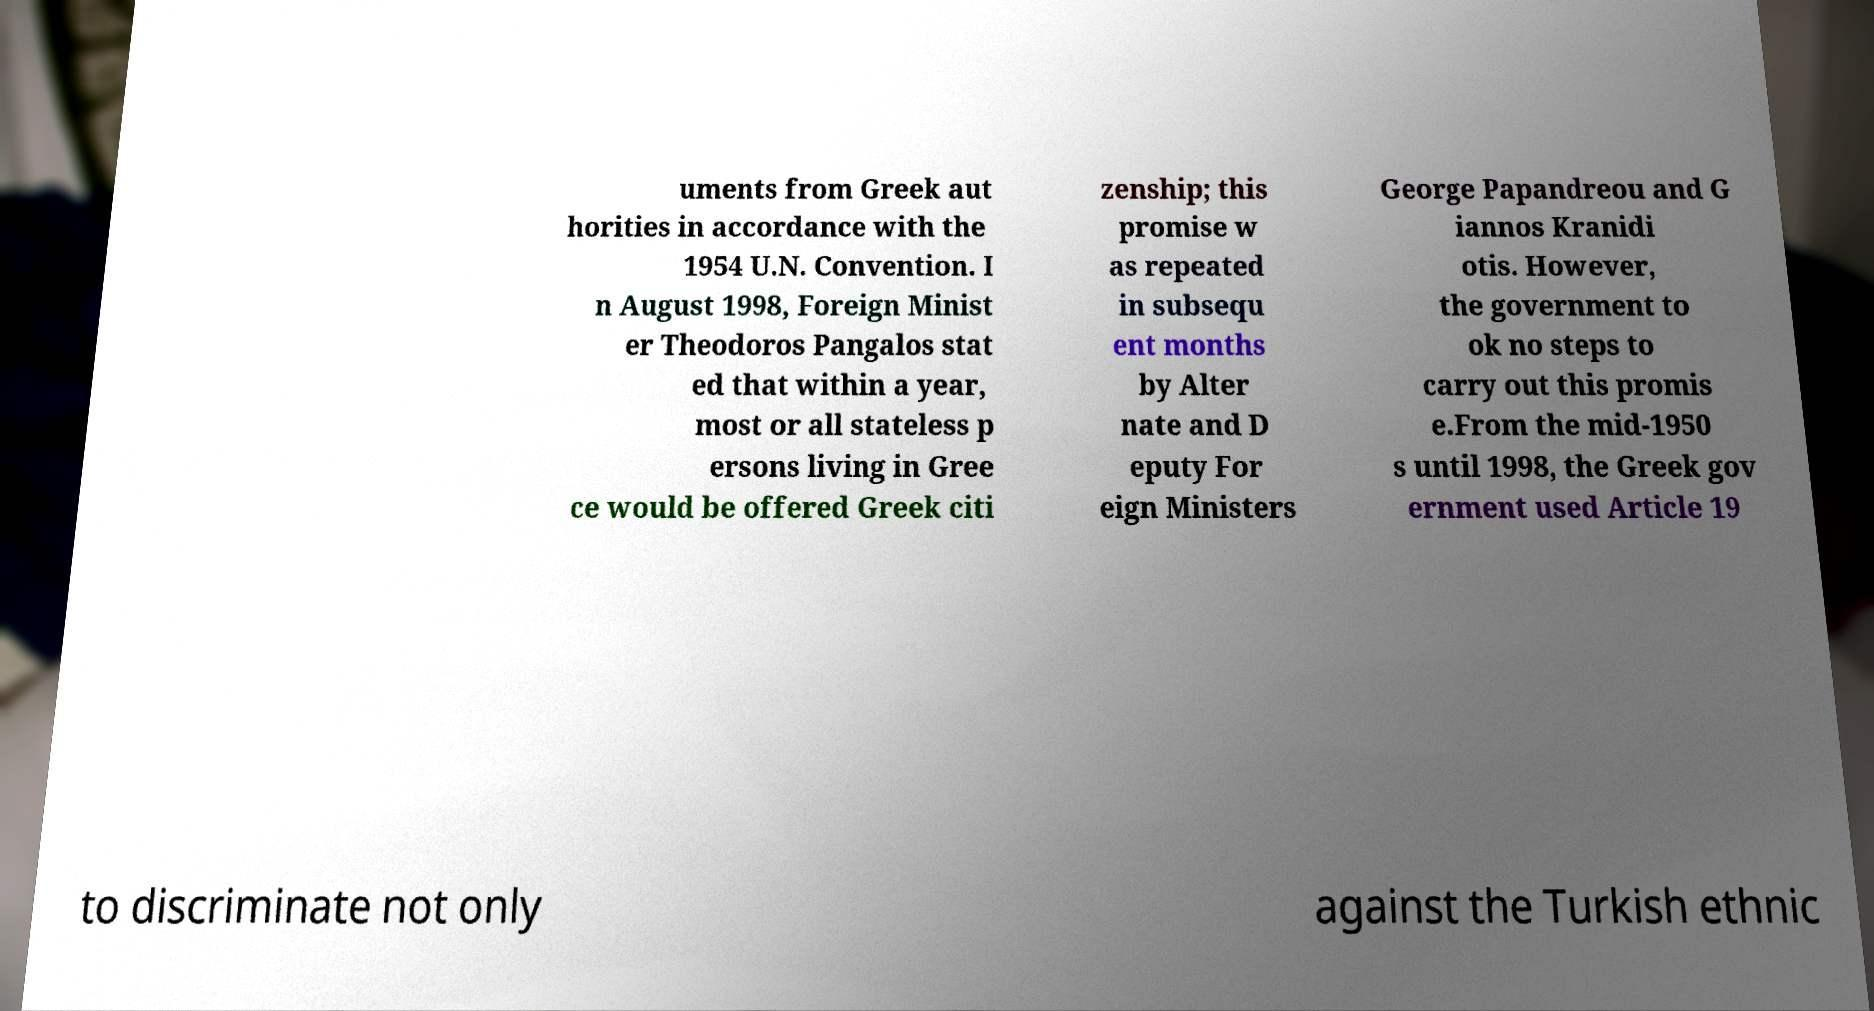Please read and relay the text visible in this image. What does it say? uments from Greek aut horities in accordance with the 1954 U.N. Convention. I n August 1998, Foreign Minist er Theodoros Pangalos stat ed that within a year, most or all stateless p ersons living in Gree ce would be offered Greek citi zenship; this promise w as repeated in subsequ ent months by Alter nate and D eputy For eign Ministers George Papandreou and G iannos Kranidi otis. However, the government to ok no steps to carry out this promis e.From the mid-1950 s until 1998, the Greek gov ernment used Article 19 to discriminate not only against the Turkish ethnic 